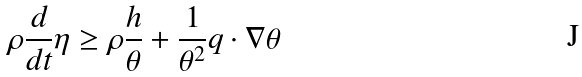<formula> <loc_0><loc_0><loc_500><loc_500>\rho \frac { d } { d t } \eta \geq \rho \frac { h } { \theta } + \frac { 1 } { \theta ^ { 2 } } q \cdot \nabla \theta</formula> 